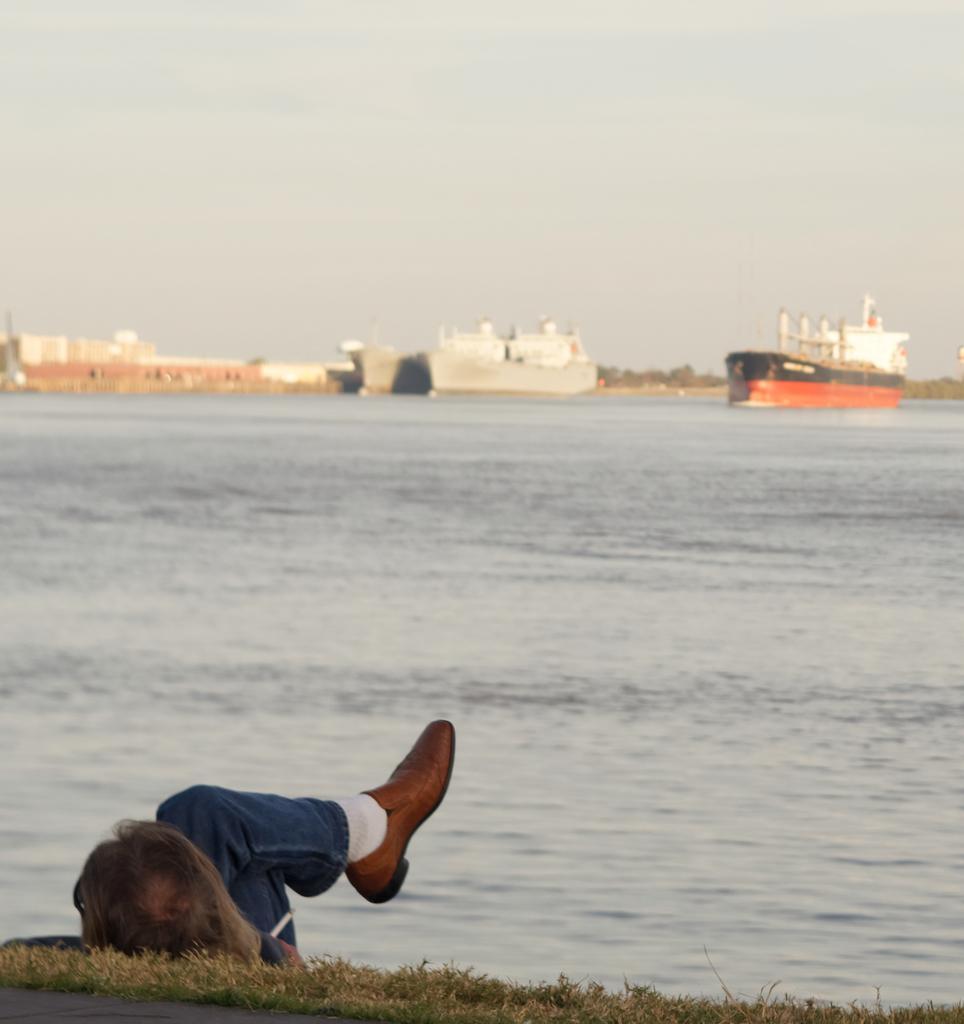Could you give a brief overview of what you see in this image? Herein this picture in the front we can see a person laying on the ground, which is fully covered with grass and in front of him we can see water present all over there and we can also see ships present in the water and in the far we can see some buildings present in blurry manner and we can also see plants and trees in the far in blurry manner and we can see the sky is cloudy. 